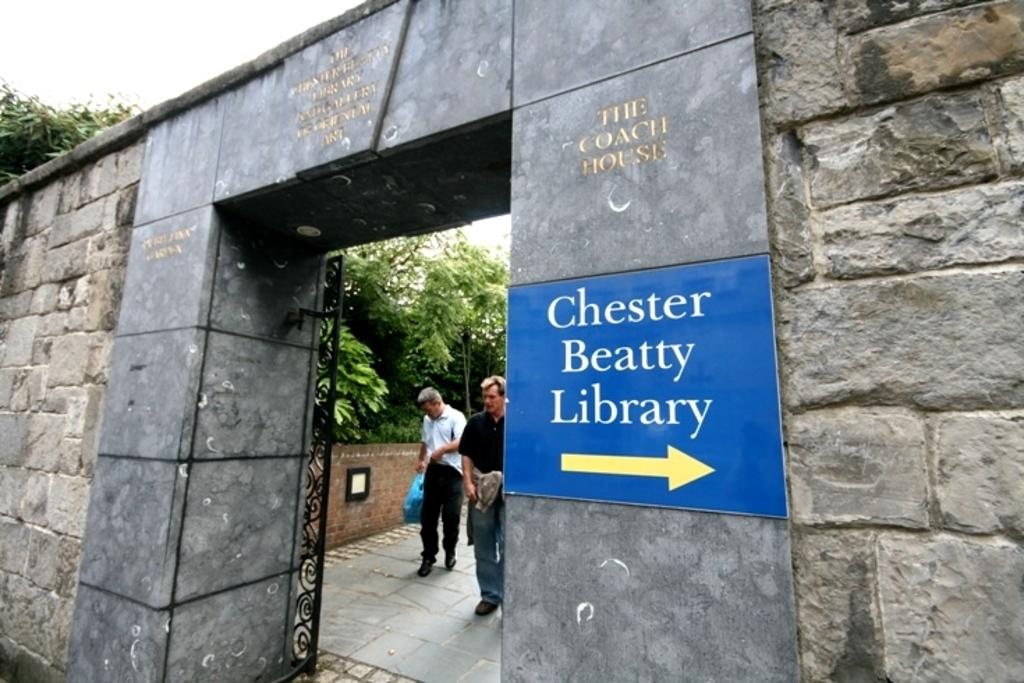What type of structure can be seen in the image? There is an arch in the image. What else is present in the image besides the arch? There is a board, people, trees, and the sky is visible at the top of the image. What type of glove is being used by the people in the image? There is no glove visible in the image; the people are not wearing gloves. 